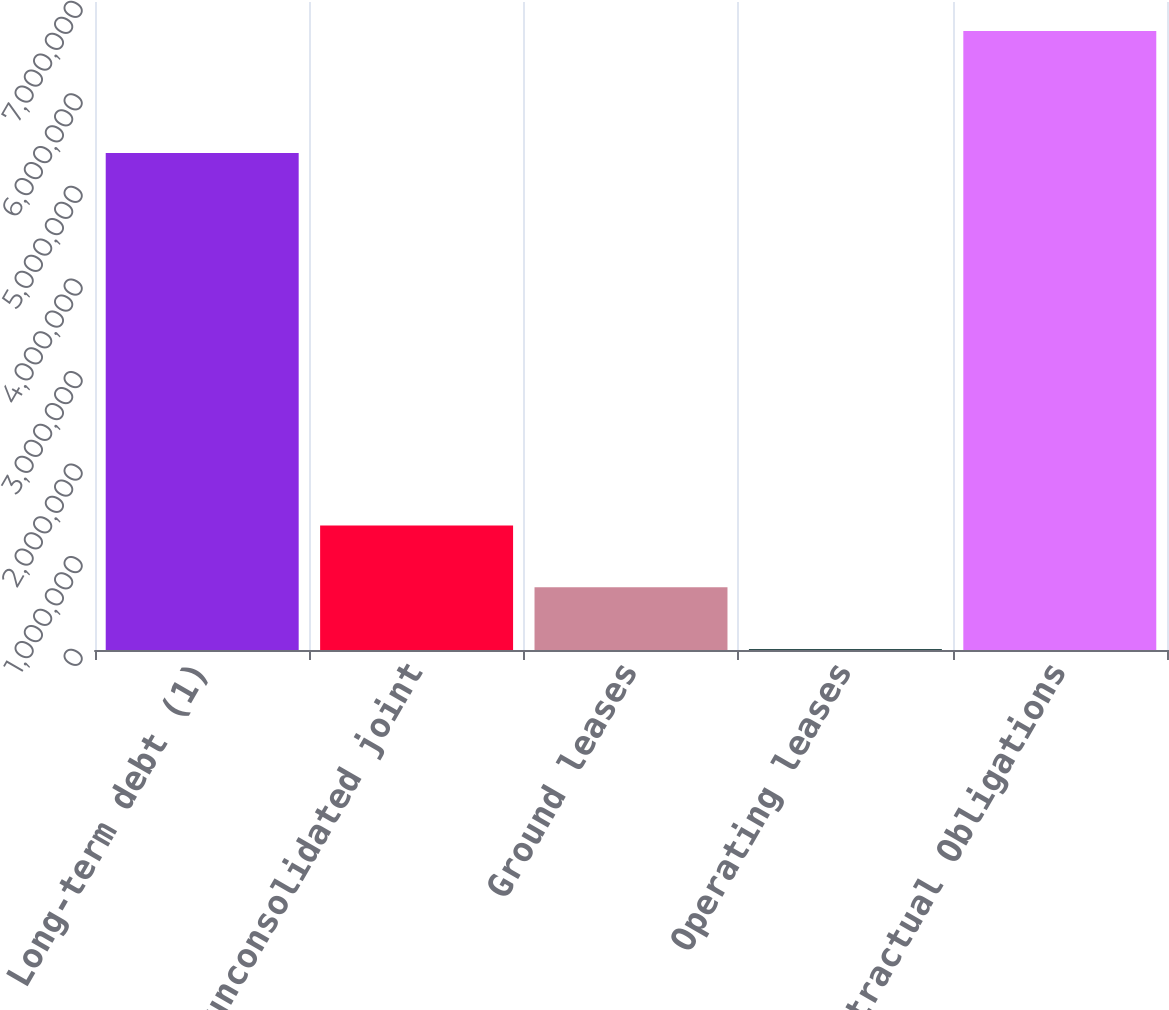<chart> <loc_0><loc_0><loc_500><loc_500><bar_chart><fcel>Long-term debt (1)<fcel>Share of unconsolidated joint<fcel>Ground leases<fcel>Operating leases<fcel>Total Contractual Obligations<nl><fcel>5.37007e+06<fcel>1.34538e+06<fcel>677777<fcel>10174<fcel>6.6862e+06<nl></chart> 